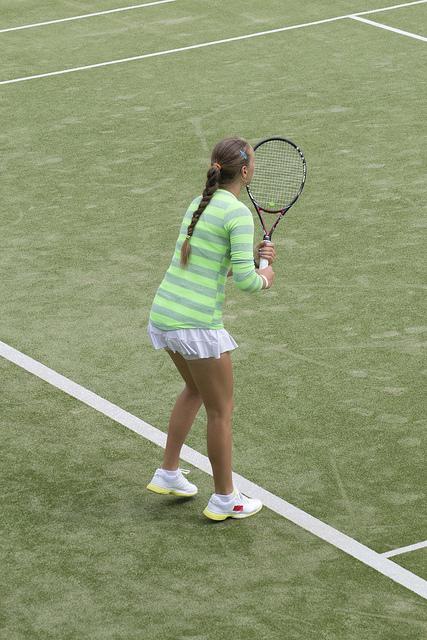Does the tennis player's shirt match her hat?
Concise answer only. No. How many hands are holding the tennis racket?
Concise answer only. 2. What is on the woman's shirt?
Give a very brief answer. Stripes. Is the woman in motion?
Give a very brief answer. No. Is she playing tennis?
Give a very brief answer. Yes. Is this woman wearing a short skirt to get attention from old men?
Keep it brief. No. Where is the person's shadow?
Quick response, please. None. 